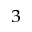<formula> <loc_0><loc_0><loc_500><loc_500>_ { 3 }</formula> 